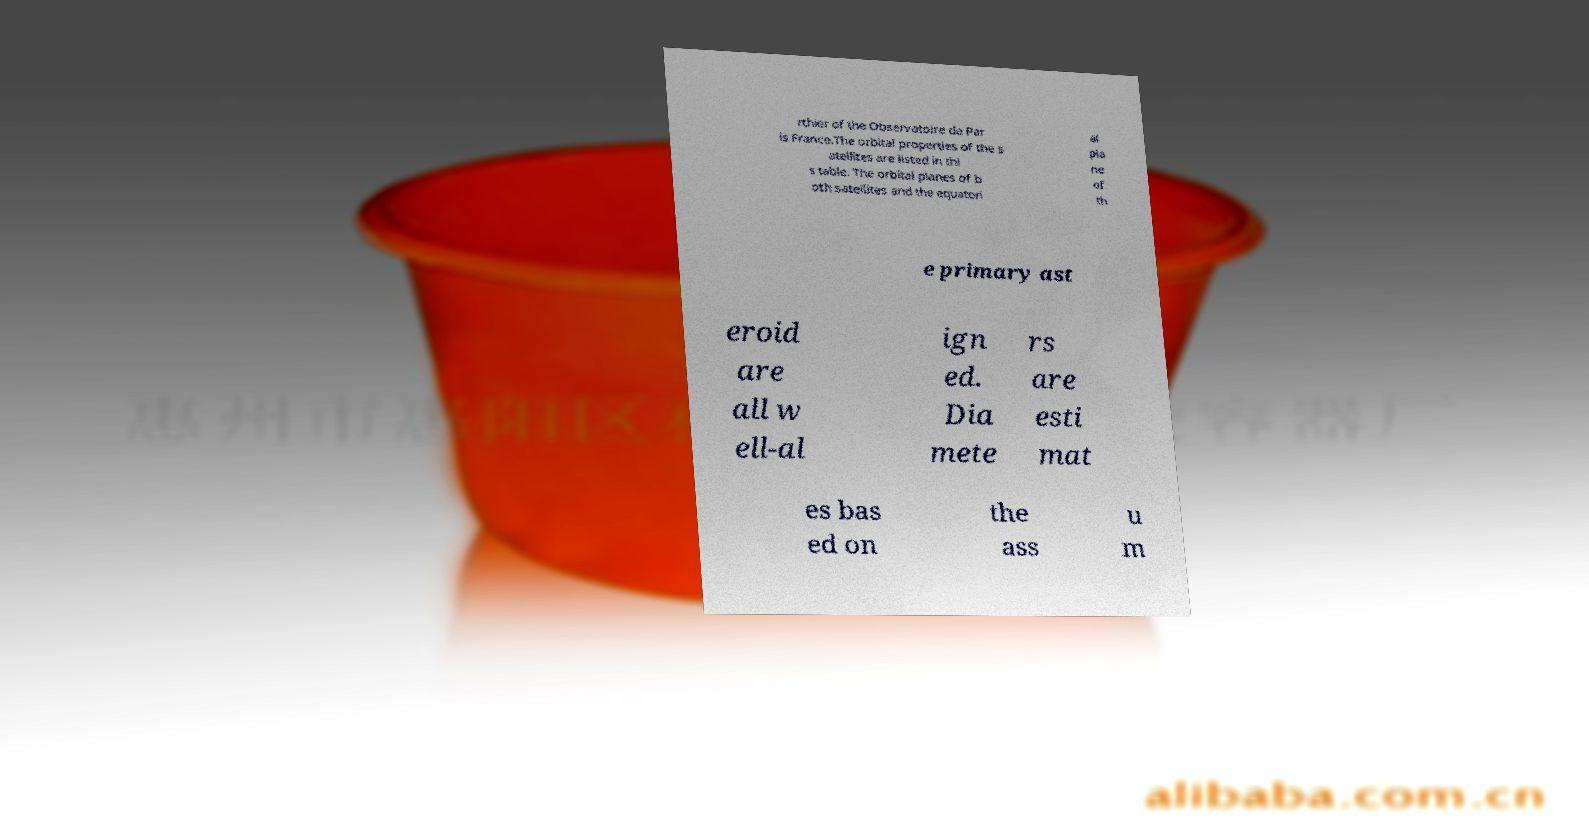Could you extract and type out the text from this image? rthier of the Observatoire de Par is France.The orbital properties of the s atellites are listed in thi s table. The orbital planes of b oth satellites and the equatori al pla ne of th e primary ast eroid are all w ell-al ign ed. Dia mete rs are esti mat es bas ed on the ass u m 